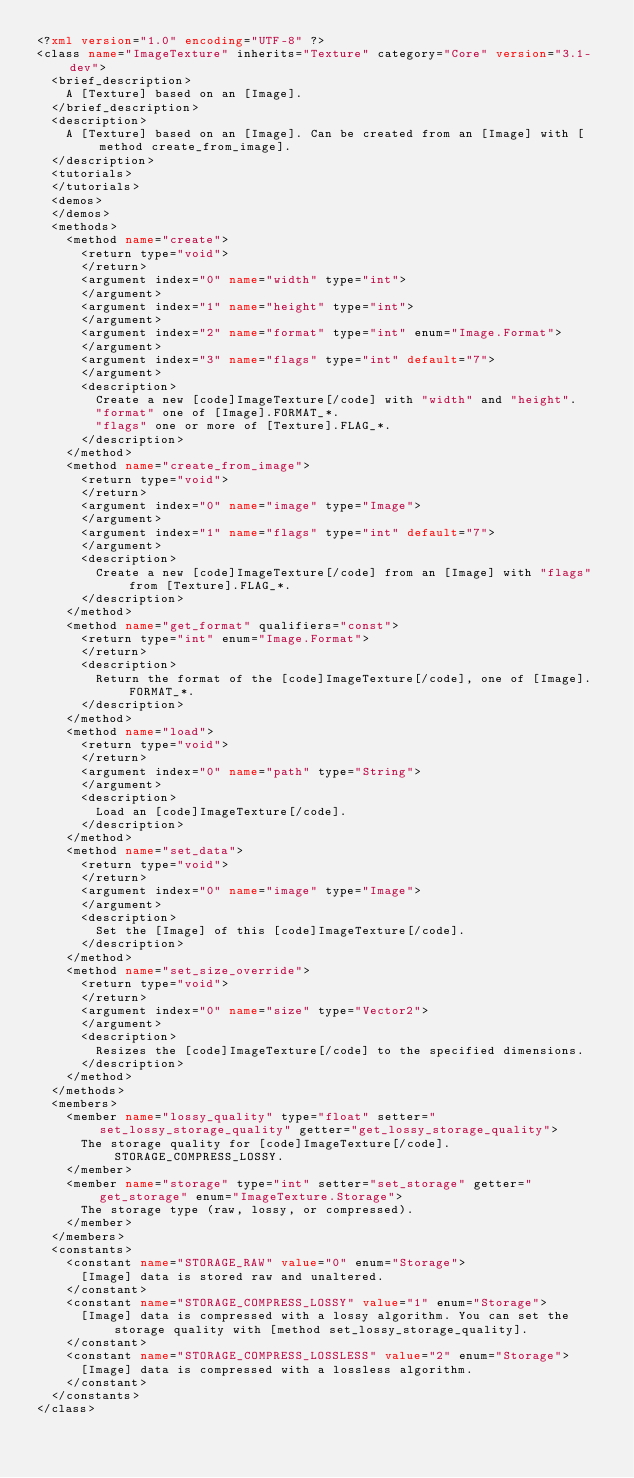Convert code to text. <code><loc_0><loc_0><loc_500><loc_500><_XML_><?xml version="1.0" encoding="UTF-8" ?>
<class name="ImageTexture" inherits="Texture" category="Core" version="3.1-dev">
	<brief_description>
		A [Texture] based on an [Image].
	</brief_description>
	<description>
		A [Texture] based on an [Image]. Can be created from an [Image] with [method create_from_image].
	</description>
	<tutorials>
	</tutorials>
	<demos>
	</demos>
	<methods>
		<method name="create">
			<return type="void">
			</return>
			<argument index="0" name="width" type="int">
			</argument>
			<argument index="1" name="height" type="int">
			</argument>
			<argument index="2" name="format" type="int" enum="Image.Format">
			</argument>
			<argument index="3" name="flags" type="int" default="7">
			</argument>
			<description>
				Create a new [code]ImageTexture[/code] with "width" and "height".
				"format" one of [Image].FORMAT_*.
				"flags" one or more of [Texture].FLAG_*.
			</description>
		</method>
		<method name="create_from_image">
			<return type="void">
			</return>
			<argument index="0" name="image" type="Image">
			</argument>
			<argument index="1" name="flags" type="int" default="7">
			</argument>
			<description>
				Create a new [code]ImageTexture[/code] from an [Image] with "flags" from [Texture].FLAG_*.
			</description>
		</method>
		<method name="get_format" qualifiers="const">
			<return type="int" enum="Image.Format">
			</return>
			<description>
				Return the format of the [code]ImageTexture[/code], one of [Image].FORMAT_*.
			</description>
		</method>
		<method name="load">
			<return type="void">
			</return>
			<argument index="0" name="path" type="String">
			</argument>
			<description>
				Load an [code]ImageTexture[/code].
			</description>
		</method>
		<method name="set_data">
			<return type="void">
			</return>
			<argument index="0" name="image" type="Image">
			</argument>
			<description>
				Set the [Image] of this [code]ImageTexture[/code].
			</description>
		</method>
		<method name="set_size_override">
			<return type="void">
			</return>
			<argument index="0" name="size" type="Vector2">
			</argument>
			<description>
				Resizes the [code]ImageTexture[/code] to the specified dimensions.
			</description>
		</method>
	</methods>
	<members>
		<member name="lossy_quality" type="float" setter="set_lossy_storage_quality" getter="get_lossy_storage_quality">
			The storage quality for [code]ImageTexture[/code].STORAGE_COMPRESS_LOSSY.
		</member>
		<member name="storage" type="int" setter="set_storage" getter="get_storage" enum="ImageTexture.Storage">
			The storage type (raw, lossy, or compressed).
		</member>
	</members>
	<constants>
		<constant name="STORAGE_RAW" value="0" enum="Storage">
			[Image] data is stored raw and unaltered.
		</constant>
		<constant name="STORAGE_COMPRESS_LOSSY" value="1" enum="Storage">
			[Image] data is compressed with a lossy algorithm. You can set the storage quality with [method set_lossy_storage_quality].
		</constant>
		<constant name="STORAGE_COMPRESS_LOSSLESS" value="2" enum="Storage">
			[Image] data is compressed with a lossless algorithm.
		</constant>
	</constants>
</class>
</code> 